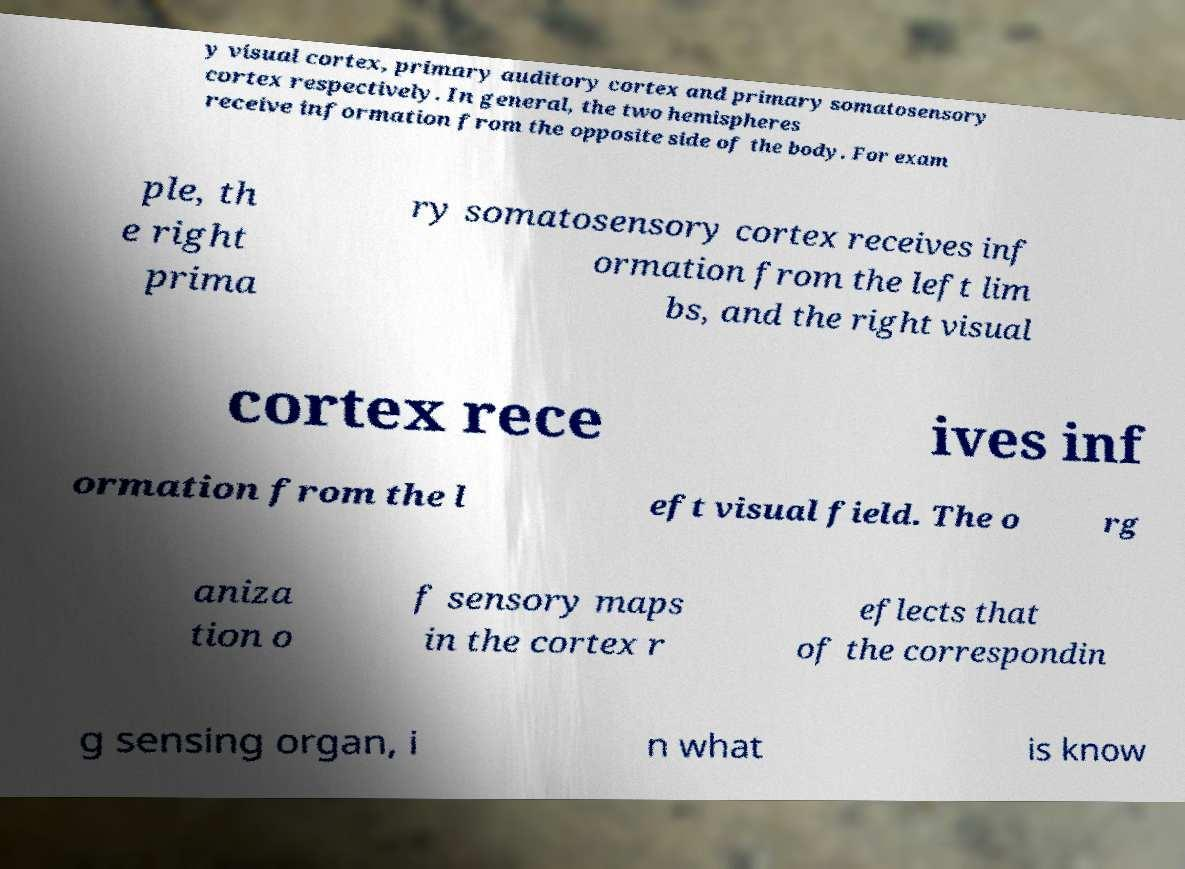Please read and relay the text visible in this image. What does it say? y visual cortex, primary auditory cortex and primary somatosensory cortex respectively. In general, the two hemispheres receive information from the opposite side of the body. For exam ple, th e right prima ry somatosensory cortex receives inf ormation from the left lim bs, and the right visual cortex rece ives inf ormation from the l eft visual field. The o rg aniza tion o f sensory maps in the cortex r eflects that of the correspondin g sensing organ, i n what is know 